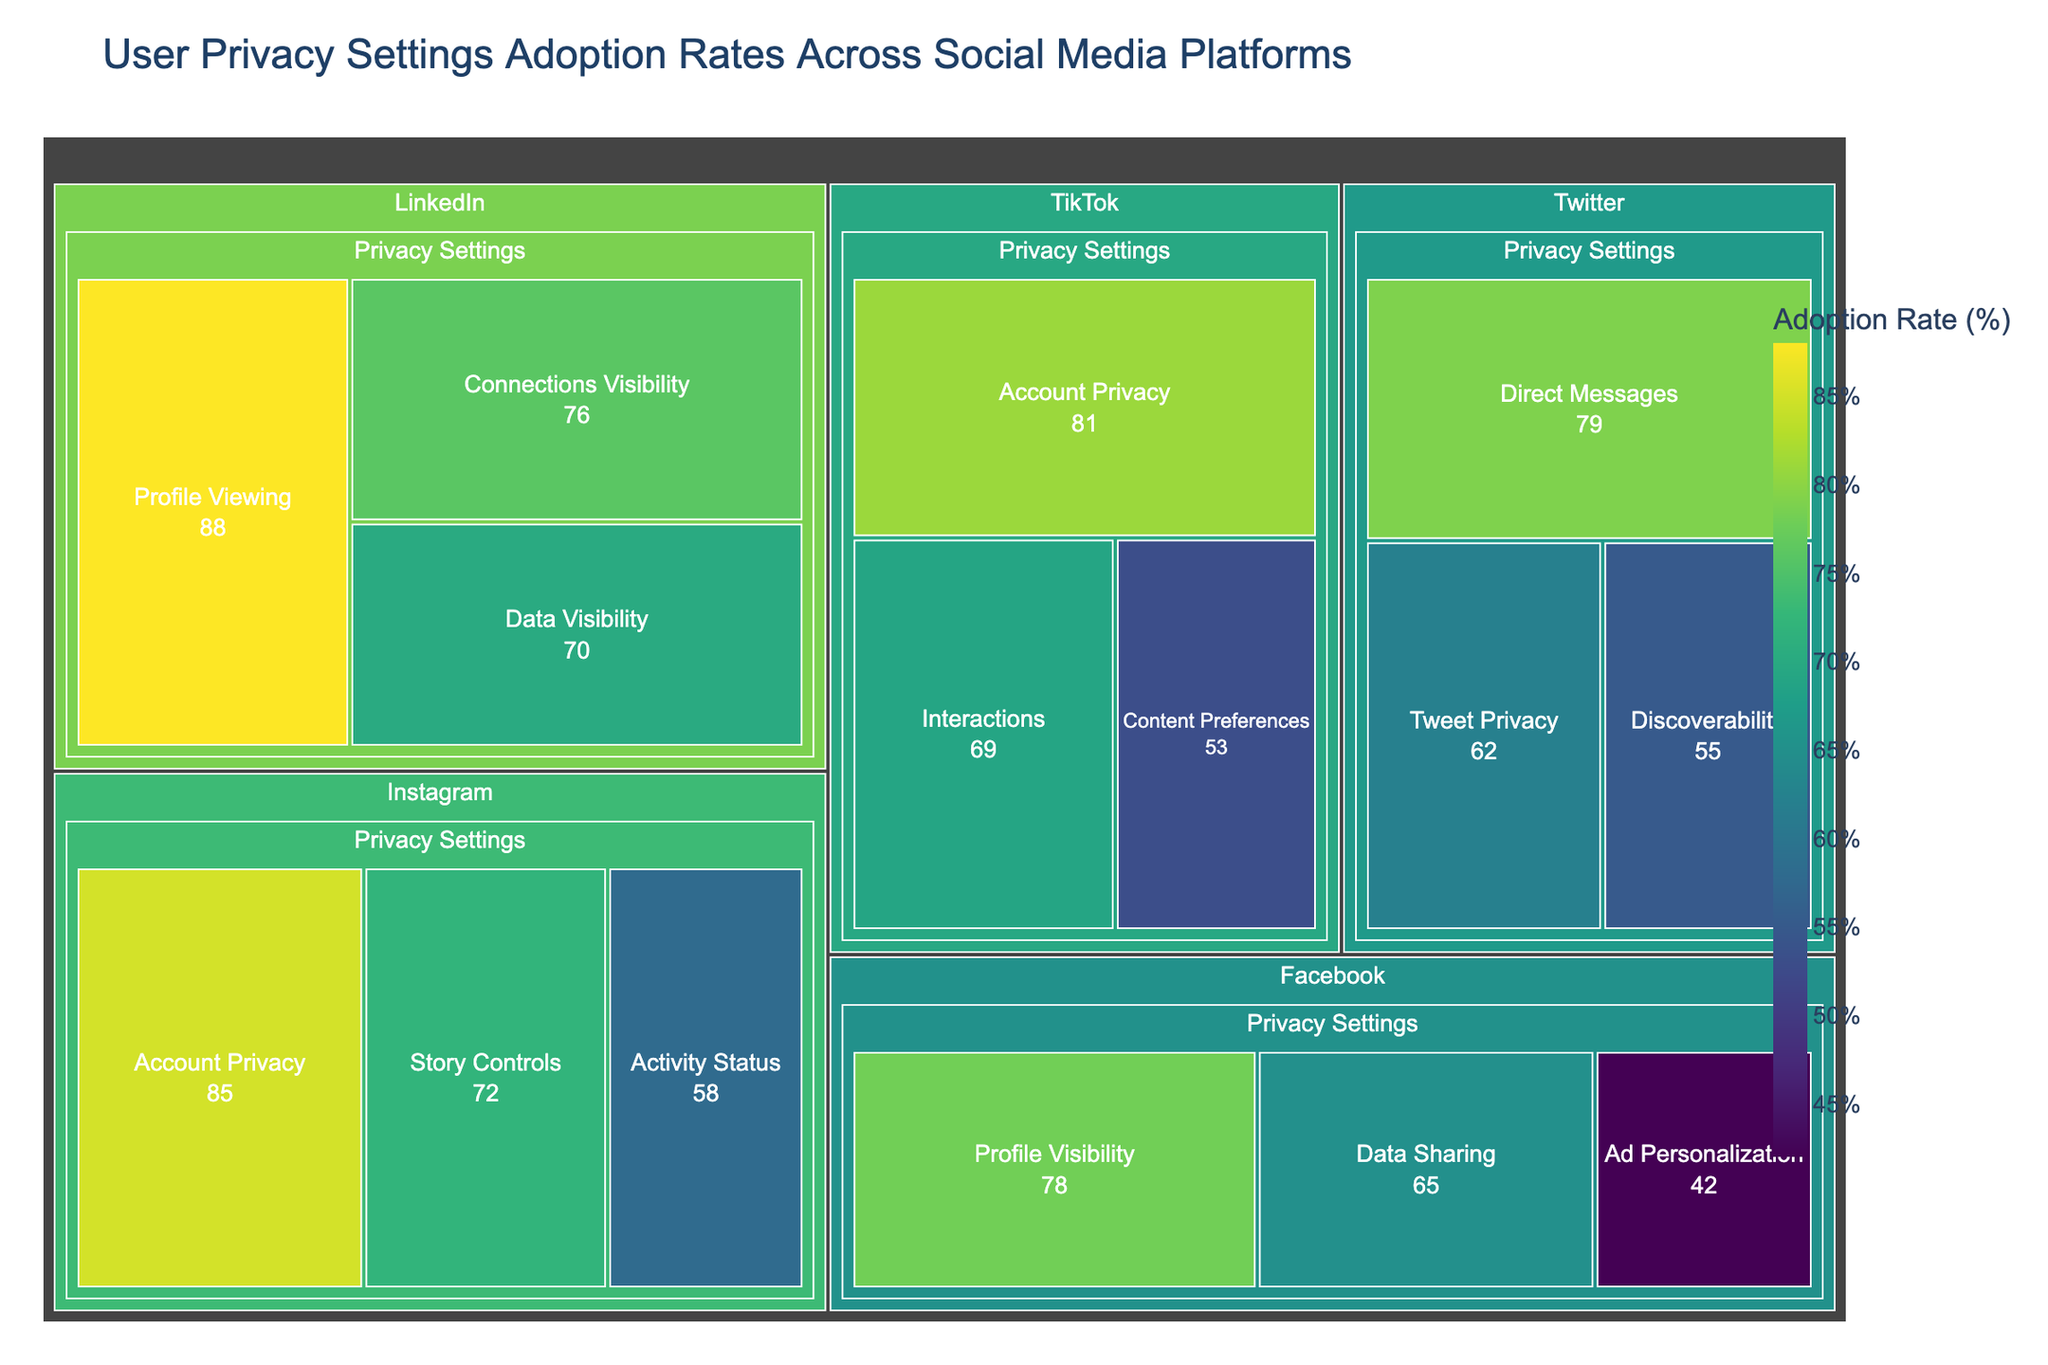What's the adoption rate for 'Account Privacy' on Instagram? Check the specific section for Instagram and look for the subcategory 'Account Privacy'. The adoption rate is labeled within that section.
Answer: 85% Which platform has the highest adoption rate for privacy settings on profile viewing? Compare the adoption rates for the 'Profile Viewing' subcategory across all platforms. The highest rate will be the answer. LinkedIn's 'Profile Viewing' has an adoption rate of 88%.
Answer: LinkedIn What's the difference in adoption rates between data sharing on Facebook and discoverability on Twitter? Locate the adoption rates for 'Data Sharing' on Facebook (65%) and 'Discoverability' on Twitter (55%). Subtract the smaller from the larger. 65% - 55% = 10%.
Answer: 10% How many subcategories are there under 'Privacy Settings' for each platform? Count the number of subcategories (each distinct label) for each platform listed under 'Privacy Settings'. Facebook has 3, Instagram has 3, Twitter has 3, and LinkedIn has 3, while TikTok also has 3.
Answer: 3 per platform Which platform overall has the highest average adoption rate for privacy settings? Calculate the average adoption rate for each platform by summing the rates of their subcategories and dividing by the number of subcategories. Compare these averages to identify the highest. LinkedIn has averages (88+76+70)/3 = 78%, which is the highest.
Answer: LinkedIn What's the range of adoption rates for the 'Privacy Settings' subcategories across all social media platforms? Find the highest and lowest adoption rates across all subcategories and subtract the smallest from the largest. The highest is 88% (LinkedIn - 'Profile Viewing') and the lowest is 42% (Facebook - 'Ad Personalization'). 88% - 42% = 46%.
Answer: 46% Which privacy setting category has the lowest adoption rate on Facebook? Look at the adoption rates for each subcategory under Facebook's 'Privacy Settings'. The lowest rate is for 'Ad Personalization' with 42%.
Answer: Ad Personalization How does TikTok's 'Content Preferences' adoption rate compare to Instagram's 'Story Controls'? Compare the labeled adoption rates for these two subcategories. TikTok's 'Content Preferences' has a rate of 53%, whereas Instagram's 'Story Controls' is 72%.
Answer: Less Can you list the three subcategories with the highest adoption rates in descending order? Identify the three highest adoption rates and order them from highest to lowest. The highest are 'Profile Viewing' on LinkedIn (88%), 'Account Privacy' on Instagram (85%), and 'Account Privacy' on TikTok (81%).
Answer: Profile Viewing > Account Privacy (Instagram) > Account Privacy (TikTok) 